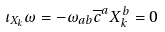<formula> <loc_0><loc_0><loc_500><loc_500>\iota _ { X _ { k } } \omega = - \omega _ { a b } \overline { c } ^ { a } X _ { k } ^ { b } = 0</formula> 